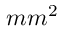Convert formula to latex. <formula><loc_0><loc_0><loc_500><loc_500>m m ^ { 2 }</formula> 